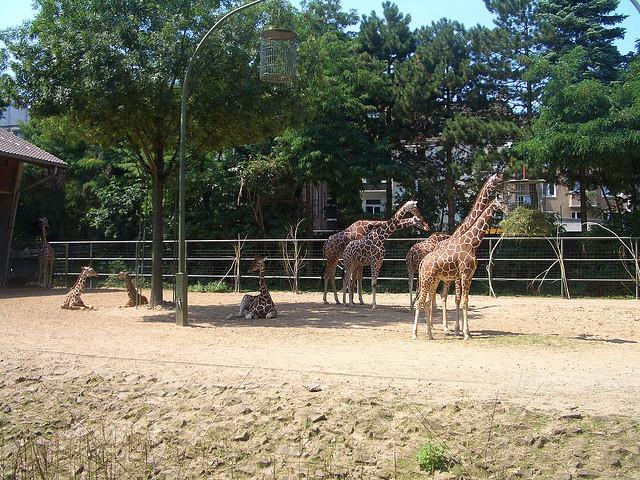What is the giraffe in the middle resting in? shade 